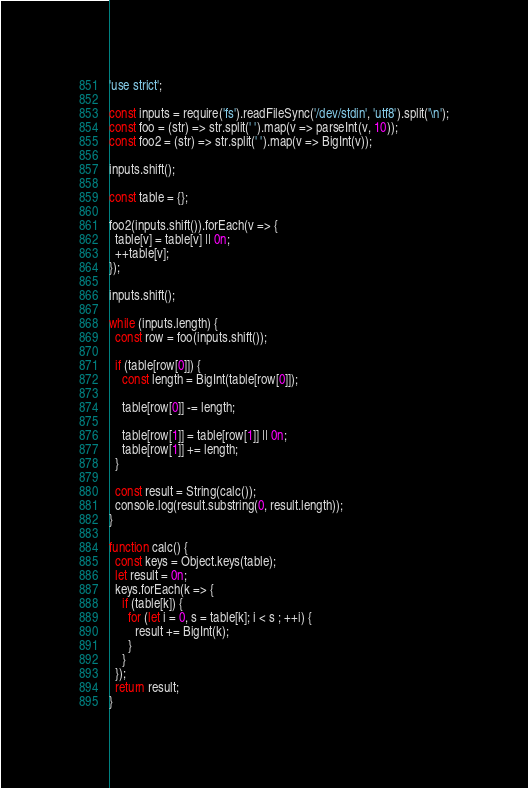<code> <loc_0><loc_0><loc_500><loc_500><_JavaScript_>'use strict';

const inputs = require('fs').readFileSync('/dev/stdin', 'utf8').split('\n');
const foo = (str) => str.split(' ').map(v => parseInt(v, 10));
const foo2 = (str) => str.split(' ').map(v => BigInt(v));

inputs.shift();

const table = {};

foo2(inputs.shift()).forEach(v => {
  table[v] = table[v] || 0n;
  ++table[v];
});

inputs.shift();

while (inputs.length) {
  const row = foo(inputs.shift());

  if (table[row[0]]) {
    const length = BigInt(table[row[0]]);

    table[row[0]] -= length;

    table[row[1]] = table[row[1]] || 0n;
    table[row[1]] += length;
  }

  const result = String(calc());
  console.log(result.substring(0, result.length));
}

function calc() {
  const keys = Object.keys(table);
  let result = 0n;
  keys.forEach(k => {
    if (table[k]) {
      for (let i = 0, s = table[k]; i < s ; ++i) {
        result += BigInt(k);
      }
    }
  });
  return result;
}
</code> 